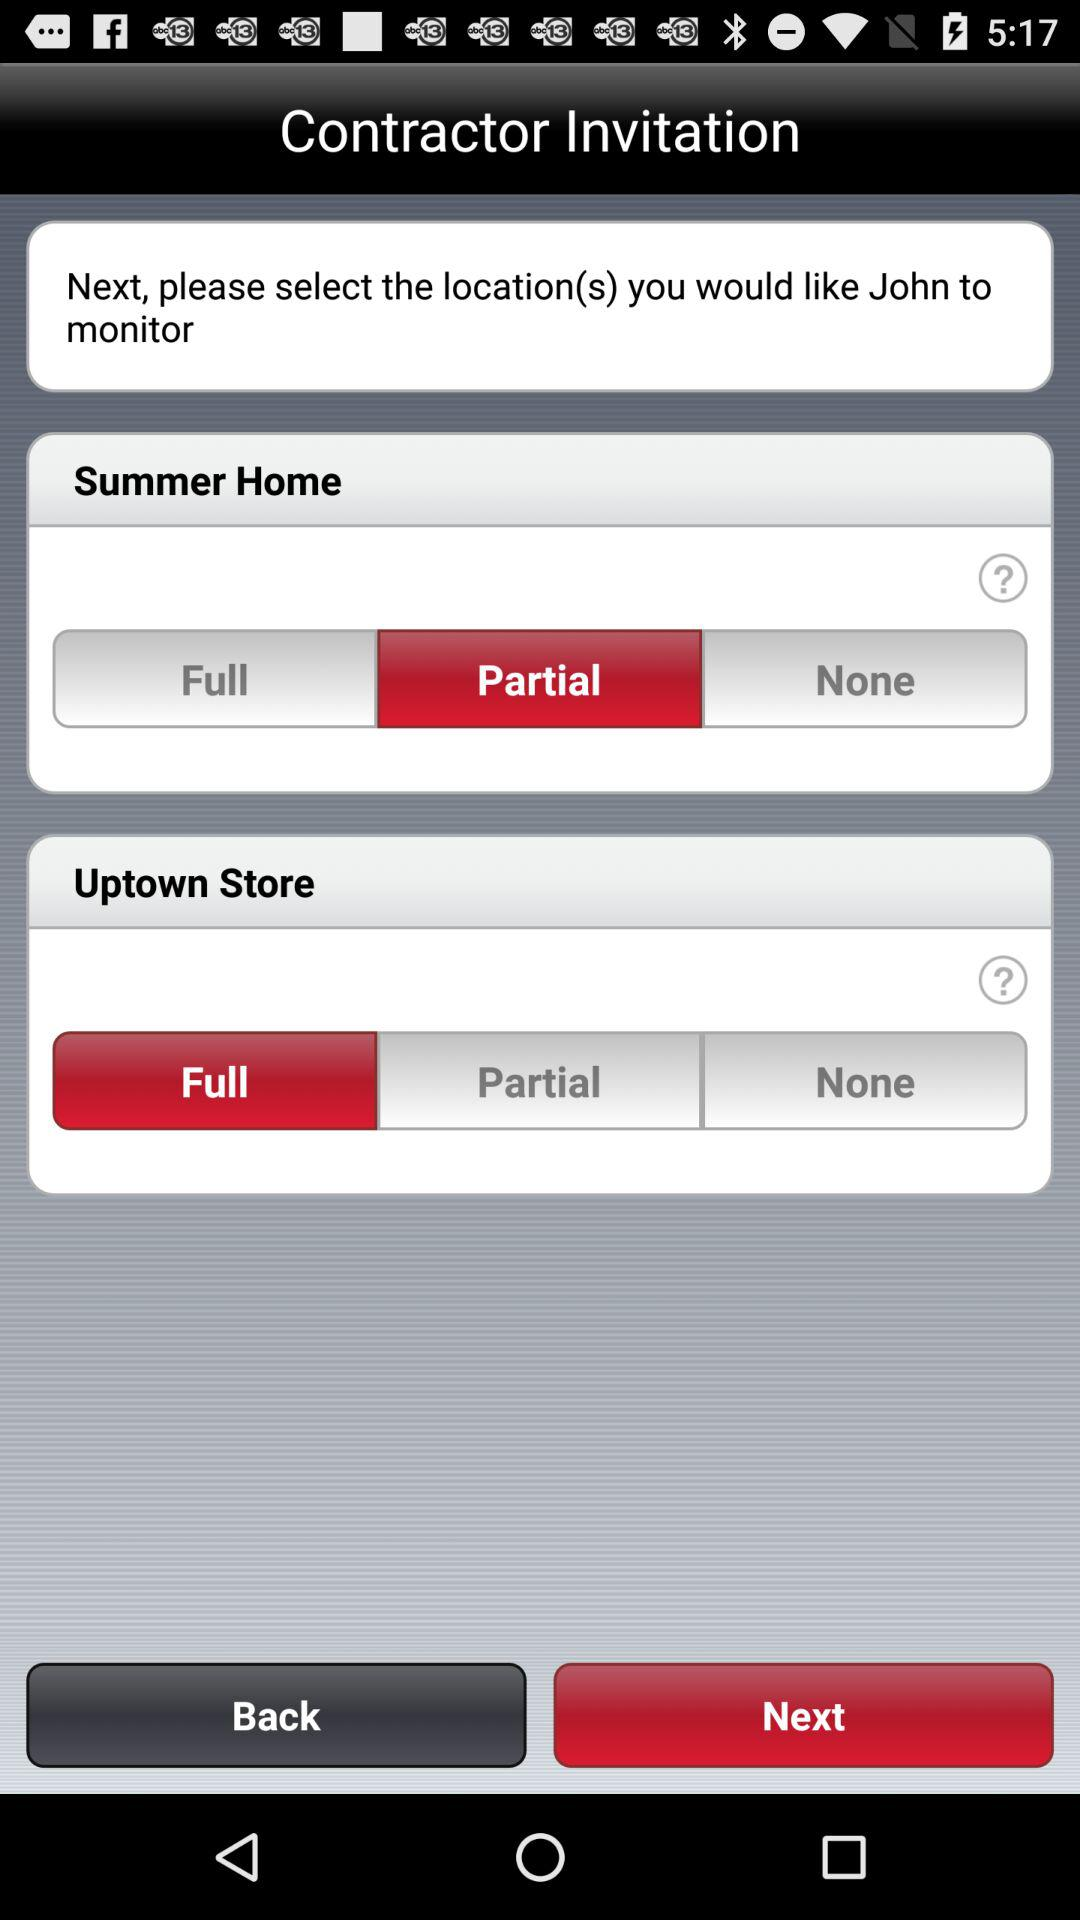How many locations are there?
Answer the question using a single word or phrase. 2 